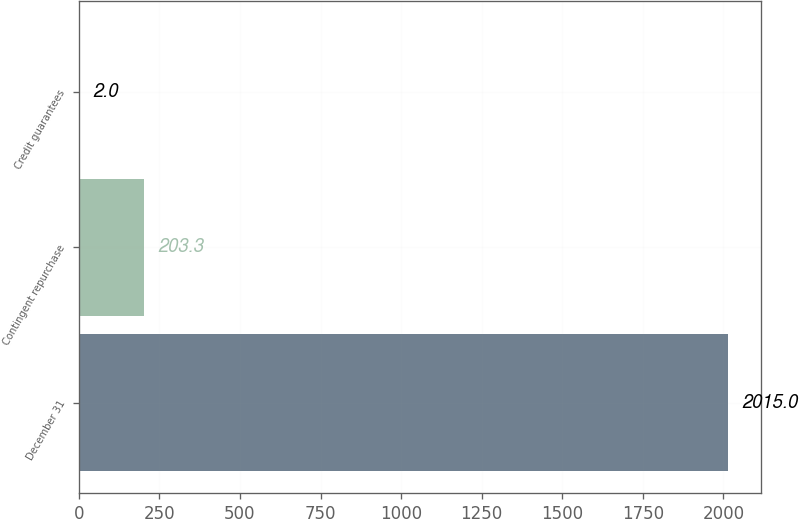Convert chart. <chart><loc_0><loc_0><loc_500><loc_500><bar_chart><fcel>December 31<fcel>Contingent repurchase<fcel>Credit guarantees<nl><fcel>2015<fcel>203.3<fcel>2<nl></chart> 